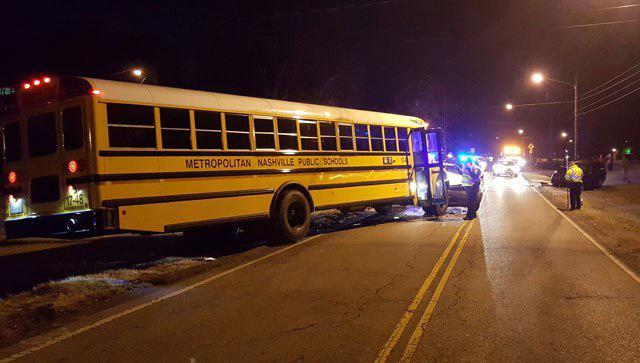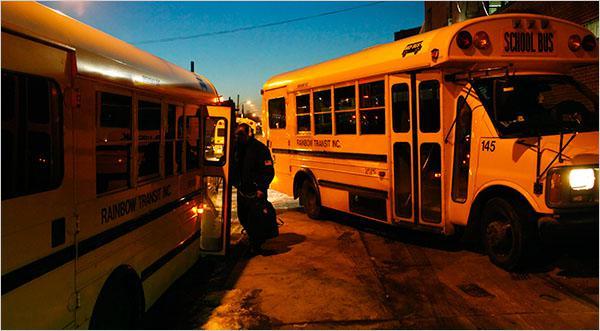The first image is the image on the left, the second image is the image on the right. For the images shown, is this caption "One image shows a school bus on fire, and the other does not." true? Answer yes or no. No. The first image is the image on the left, the second image is the image on the right. For the images shown, is this caption "At least one school bus is on fire in only one of the images." true? Answer yes or no. No. 